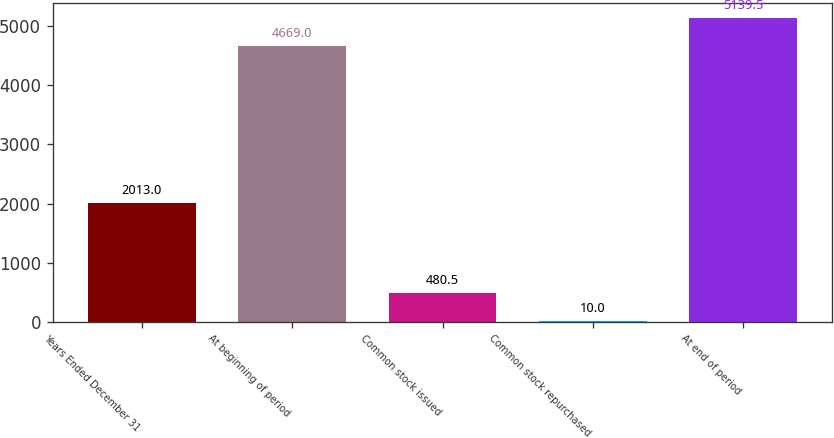<chart> <loc_0><loc_0><loc_500><loc_500><bar_chart><fcel>Years Ended December 31<fcel>At beginning of period<fcel>Common stock issued<fcel>Common stock repurchased<fcel>At end of period<nl><fcel>2013<fcel>4669<fcel>480.5<fcel>10<fcel>5139.5<nl></chart> 